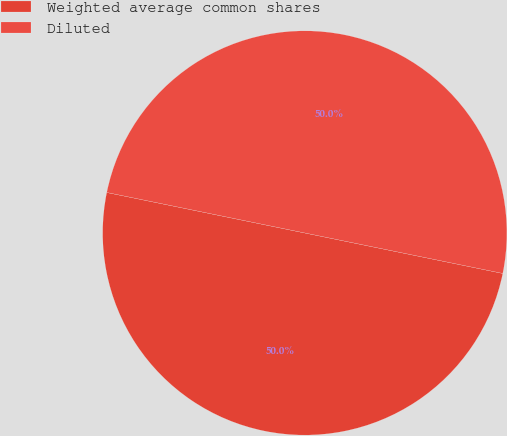Convert chart. <chart><loc_0><loc_0><loc_500><loc_500><pie_chart><fcel>Weighted average common shares<fcel>Diluted<nl><fcel>50.0%<fcel>50.0%<nl></chart> 